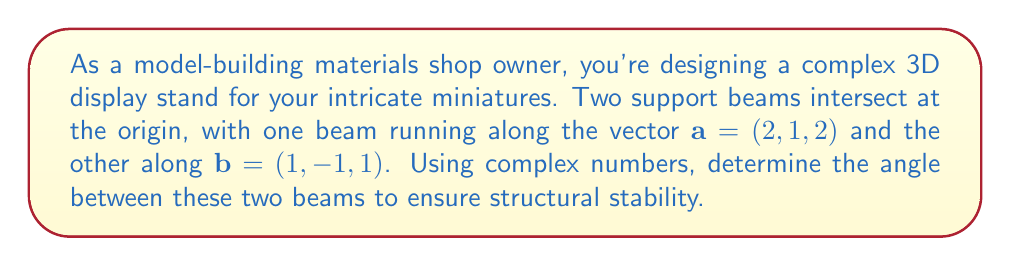Teach me how to tackle this problem. To find the angle between two vectors using complex numbers, we'll follow these steps:

1) First, we need to represent our vectors as complex numbers. We'll use the magnitude of the vector as the modulus and the direction as the argument.

2) For vector $\mathbf{a} = (2, 1, 2)$:
   Magnitude: $|\mathbf{a}| = \sqrt{2^2 + 1^2 + 2^2} = \sqrt{9} = 3$
   Complex representation: $z_a = 3(\frac{2}{3} + \frac{1}{3}i + \frac{2}{3}j)$

3) For vector $\mathbf{b} = (1, -1, 1)$:
   Magnitude: $|\mathbf{b}| = \sqrt{1^2 + (-1)^2 + 1^2} = \sqrt{3}$
   Complex representation: $z_b = \sqrt{3}(\frac{1}{\sqrt{3}} - \frac{1}{\sqrt{3}}i + \frac{1}{\sqrt{3}}j)$

4) The angle $\theta$ between two complex numbers $z_1$ and $z_2$ is given by:

   $$\cos \theta = \frac{\text{Re}(z_1 \overline{z_2})}{|z_1||z_2|}$$

   where $\overline{z_2}$ is the complex conjugate of $z_2$ and $\text{Re}$ denotes the real part.

5) Calculating $z_a \overline{z_b}$:
   $z_a \overline{z_b} = 3\sqrt{3}(\frac{2}{3} + \frac{1}{3}i + \frac{2}{3}j)(\frac{1}{\sqrt{3}} + \frac{1}{\sqrt{3}}i - \frac{1}{\sqrt{3}}j)$
   $= 3\sqrt{3}(\frac{2}{3\sqrt{3}} + \frac{2}{3\sqrt{3}}i - \frac{2}{3\sqrt{3}}j + \frac{1}{3\sqrt{3}}i + \frac{1}{3\sqrt{3}} + \frac{1}{3\sqrt{3}}j + \frac{2}{3\sqrt{3}}j - \frac{2}{3\sqrt{3}}i + \frac{2}{3\sqrt{3}})$
   $= 3\sqrt{3}(\frac{5}{3\sqrt{3}} + \frac{1}{3\sqrt{3}}i + \frac{1}{3\sqrt{3}}j)$

6) The real part of this is $5$.

7) Now we can calculate $\cos \theta$:
   $$\cos \theta = \frac{5}{3\sqrt{3}} = \frac{5\sqrt{3}}{9}$$

8) To get $\theta$, we take the inverse cosine (arccos):
   $$\theta = \arccos(\frac{5\sqrt{3}}{9})$$

9) Converting to degrees:
   $$\theta \approx 35.26°$$
Answer: $35.26°$ 